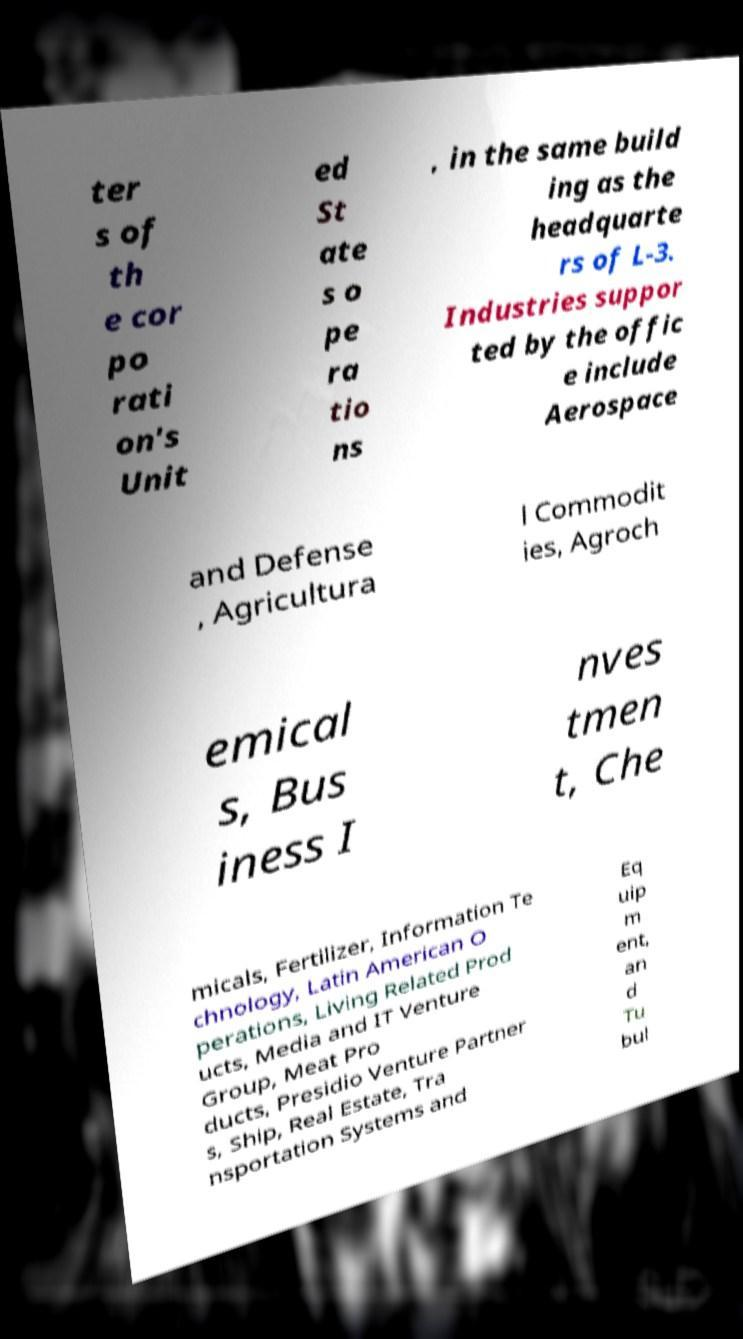Could you extract and type out the text from this image? ter s of th e cor po rati on's Unit ed St ate s o pe ra tio ns , in the same build ing as the headquarte rs of L-3. Industries suppor ted by the offic e include Aerospace and Defense , Agricultura l Commodit ies, Agroch emical s, Bus iness I nves tmen t, Che micals, Fertilizer, Information Te chnology, Latin American O perations, Living Related Prod ucts, Media and IT Venture Group, Meat Pro ducts, Presidio Venture Partner s, Ship, Real Estate, Tra nsportation Systems and Eq uip m ent, an d Tu bul 